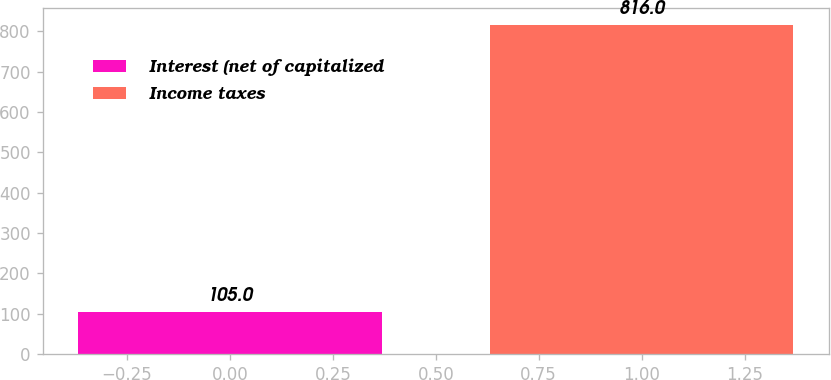Convert chart to OTSL. <chart><loc_0><loc_0><loc_500><loc_500><bar_chart><fcel>Interest (net of capitalized<fcel>Income taxes<nl><fcel>105<fcel>816<nl></chart> 